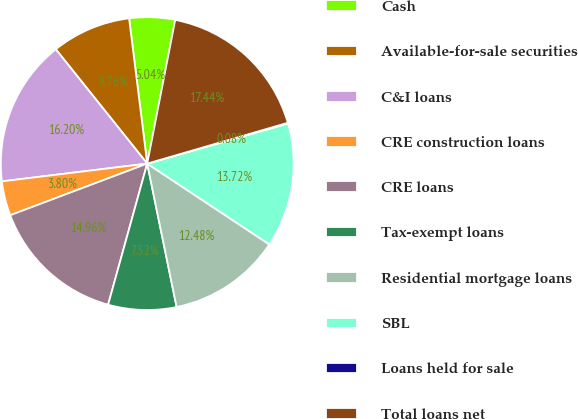<chart> <loc_0><loc_0><loc_500><loc_500><pie_chart><fcel>Cash<fcel>Available-for-sale securities<fcel>C&I loans<fcel>CRE construction loans<fcel>CRE loans<fcel>Tax-exempt loans<fcel>Residential mortgage loans<fcel>SBL<fcel>Loans held for sale<fcel>Total loans net<nl><fcel>5.04%<fcel>8.76%<fcel>16.2%<fcel>3.8%<fcel>14.96%<fcel>7.52%<fcel>12.48%<fcel>13.72%<fcel>0.08%<fcel>17.44%<nl></chart> 